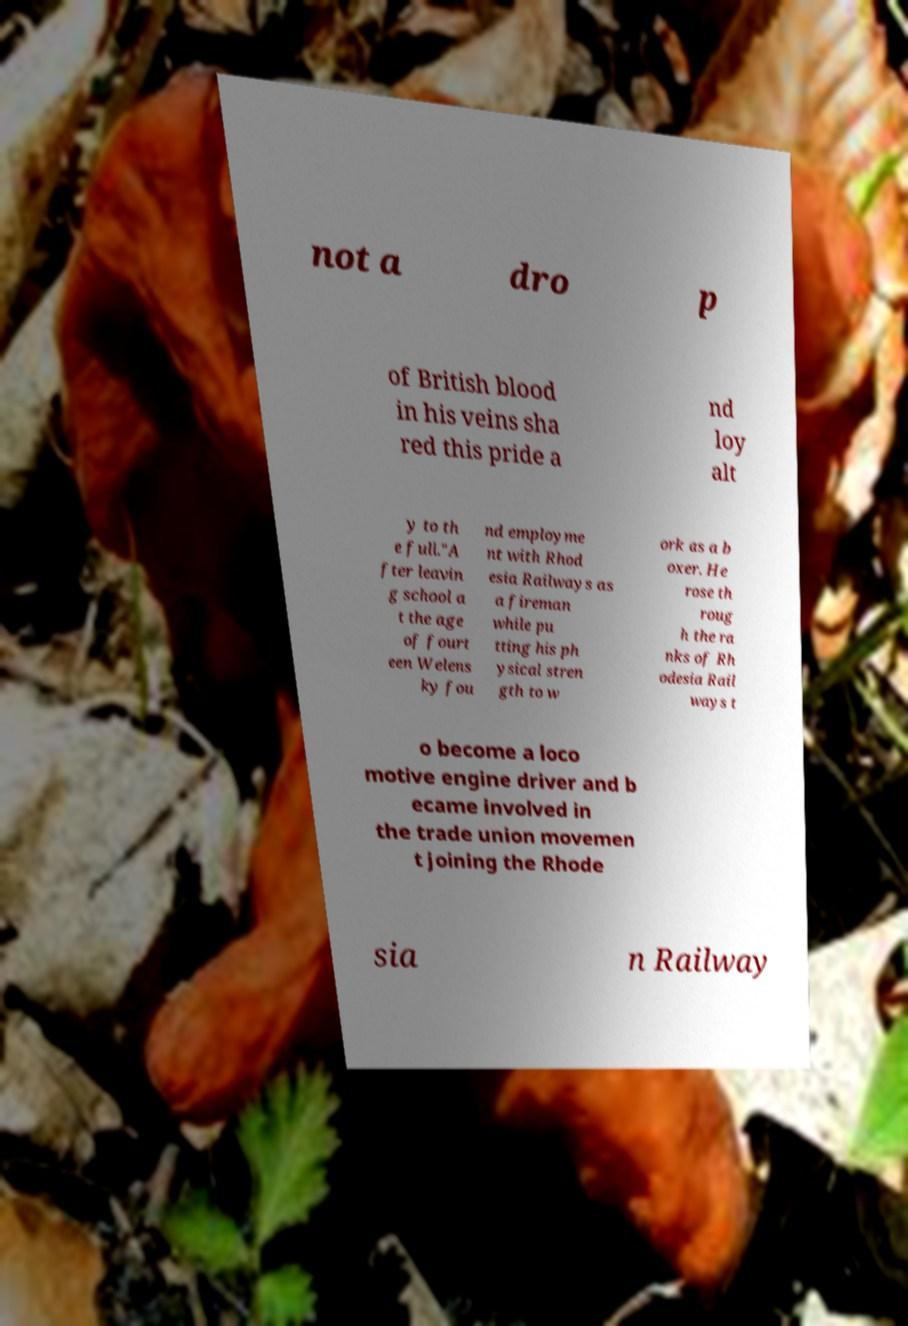Can you accurately transcribe the text from the provided image for me? not a dro p of British blood in his veins sha red this pride a nd loy alt y to th e full."A fter leavin g school a t the age of fourt een Welens ky fou nd employme nt with Rhod esia Railways as a fireman while pu tting his ph ysical stren gth to w ork as a b oxer. He rose th roug h the ra nks of Rh odesia Rail ways t o become a loco motive engine driver and b ecame involved in the trade union movemen t joining the Rhode sia n Railway 